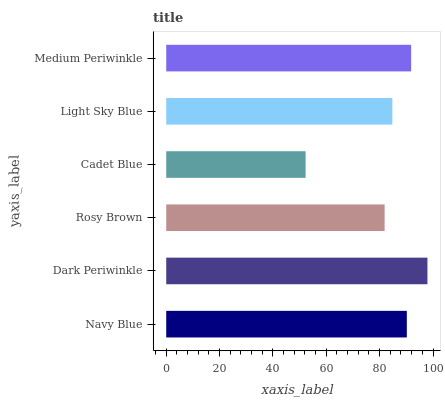Is Cadet Blue the minimum?
Answer yes or no. Yes. Is Dark Periwinkle the maximum?
Answer yes or no. Yes. Is Rosy Brown the minimum?
Answer yes or no. No. Is Rosy Brown the maximum?
Answer yes or no. No. Is Dark Periwinkle greater than Rosy Brown?
Answer yes or no. Yes. Is Rosy Brown less than Dark Periwinkle?
Answer yes or no. Yes. Is Rosy Brown greater than Dark Periwinkle?
Answer yes or no. No. Is Dark Periwinkle less than Rosy Brown?
Answer yes or no. No. Is Navy Blue the high median?
Answer yes or no. Yes. Is Light Sky Blue the low median?
Answer yes or no. Yes. Is Medium Periwinkle the high median?
Answer yes or no. No. Is Dark Periwinkle the low median?
Answer yes or no. No. 